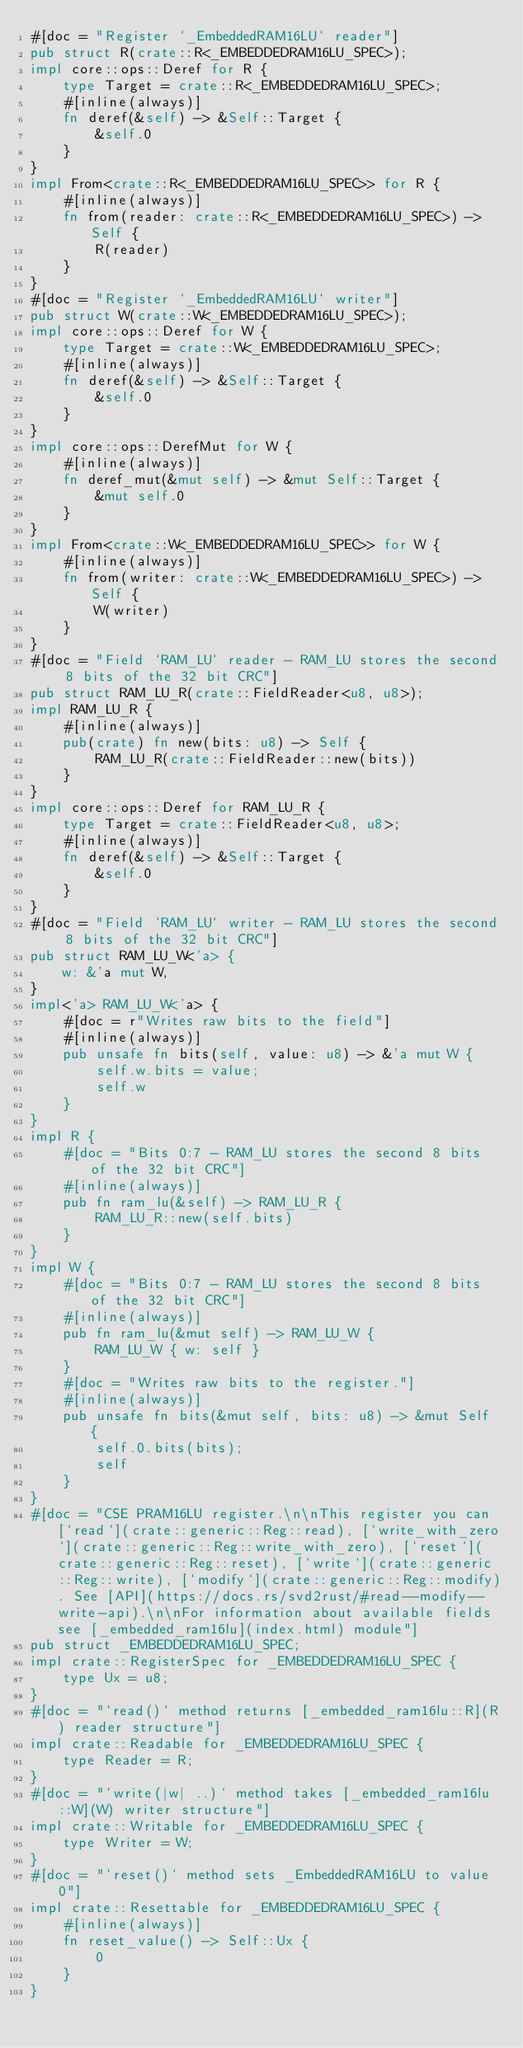<code> <loc_0><loc_0><loc_500><loc_500><_Rust_>#[doc = "Register `_EmbeddedRAM16LU` reader"]
pub struct R(crate::R<_EMBEDDEDRAM16LU_SPEC>);
impl core::ops::Deref for R {
    type Target = crate::R<_EMBEDDEDRAM16LU_SPEC>;
    #[inline(always)]
    fn deref(&self) -> &Self::Target {
        &self.0
    }
}
impl From<crate::R<_EMBEDDEDRAM16LU_SPEC>> for R {
    #[inline(always)]
    fn from(reader: crate::R<_EMBEDDEDRAM16LU_SPEC>) -> Self {
        R(reader)
    }
}
#[doc = "Register `_EmbeddedRAM16LU` writer"]
pub struct W(crate::W<_EMBEDDEDRAM16LU_SPEC>);
impl core::ops::Deref for W {
    type Target = crate::W<_EMBEDDEDRAM16LU_SPEC>;
    #[inline(always)]
    fn deref(&self) -> &Self::Target {
        &self.0
    }
}
impl core::ops::DerefMut for W {
    #[inline(always)]
    fn deref_mut(&mut self) -> &mut Self::Target {
        &mut self.0
    }
}
impl From<crate::W<_EMBEDDEDRAM16LU_SPEC>> for W {
    #[inline(always)]
    fn from(writer: crate::W<_EMBEDDEDRAM16LU_SPEC>) -> Self {
        W(writer)
    }
}
#[doc = "Field `RAM_LU` reader - RAM_LU stores the second 8 bits of the 32 bit CRC"]
pub struct RAM_LU_R(crate::FieldReader<u8, u8>);
impl RAM_LU_R {
    #[inline(always)]
    pub(crate) fn new(bits: u8) -> Self {
        RAM_LU_R(crate::FieldReader::new(bits))
    }
}
impl core::ops::Deref for RAM_LU_R {
    type Target = crate::FieldReader<u8, u8>;
    #[inline(always)]
    fn deref(&self) -> &Self::Target {
        &self.0
    }
}
#[doc = "Field `RAM_LU` writer - RAM_LU stores the second 8 bits of the 32 bit CRC"]
pub struct RAM_LU_W<'a> {
    w: &'a mut W,
}
impl<'a> RAM_LU_W<'a> {
    #[doc = r"Writes raw bits to the field"]
    #[inline(always)]
    pub unsafe fn bits(self, value: u8) -> &'a mut W {
        self.w.bits = value;
        self.w
    }
}
impl R {
    #[doc = "Bits 0:7 - RAM_LU stores the second 8 bits of the 32 bit CRC"]
    #[inline(always)]
    pub fn ram_lu(&self) -> RAM_LU_R {
        RAM_LU_R::new(self.bits)
    }
}
impl W {
    #[doc = "Bits 0:7 - RAM_LU stores the second 8 bits of the 32 bit CRC"]
    #[inline(always)]
    pub fn ram_lu(&mut self) -> RAM_LU_W {
        RAM_LU_W { w: self }
    }
    #[doc = "Writes raw bits to the register."]
    #[inline(always)]
    pub unsafe fn bits(&mut self, bits: u8) -> &mut Self {
        self.0.bits(bits);
        self
    }
}
#[doc = "CSE PRAM16LU register.\n\nThis register you can [`read`](crate::generic::Reg::read), [`write_with_zero`](crate::generic::Reg::write_with_zero), [`reset`](crate::generic::Reg::reset), [`write`](crate::generic::Reg::write), [`modify`](crate::generic::Reg::modify). See [API](https://docs.rs/svd2rust/#read--modify--write-api).\n\nFor information about available fields see [_embedded_ram16lu](index.html) module"]
pub struct _EMBEDDEDRAM16LU_SPEC;
impl crate::RegisterSpec for _EMBEDDEDRAM16LU_SPEC {
    type Ux = u8;
}
#[doc = "`read()` method returns [_embedded_ram16lu::R](R) reader structure"]
impl crate::Readable for _EMBEDDEDRAM16LU_SPEC {
    type Reader = R;
}
#[doc = "`write(|w| ..)` method takes [_embedded_ram16lu::W](W) writer structure"]
impl crate::Writable for _EMBEDDEDRAM16LU_SPEC {
    type Writer = W;
}
#[doc = "`reset()` method sets _EmbeddedRAM16LU to value 0"]
impl crate::Resettable for _EMBEDDEDRAM16LU_SPEC {
    #[inline(always)]
    fn reset_value() -> Self::Ux {
        0
    }
}
</code> 